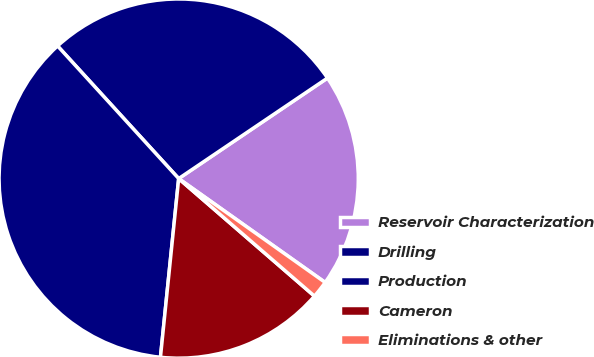<chart> <loc_0><loc_0><loc_500><loc_500><pie_chart><fcel>Reservoir Characterization<fcel>Drilling<fcel>Production<fcel>Cameron<fcel>Eliminations & other<nl><fcel>19.27%<fcel>27.32%<fcel>36.6%<fcel>15.26%<fcel>1.54%<nl></chart> 